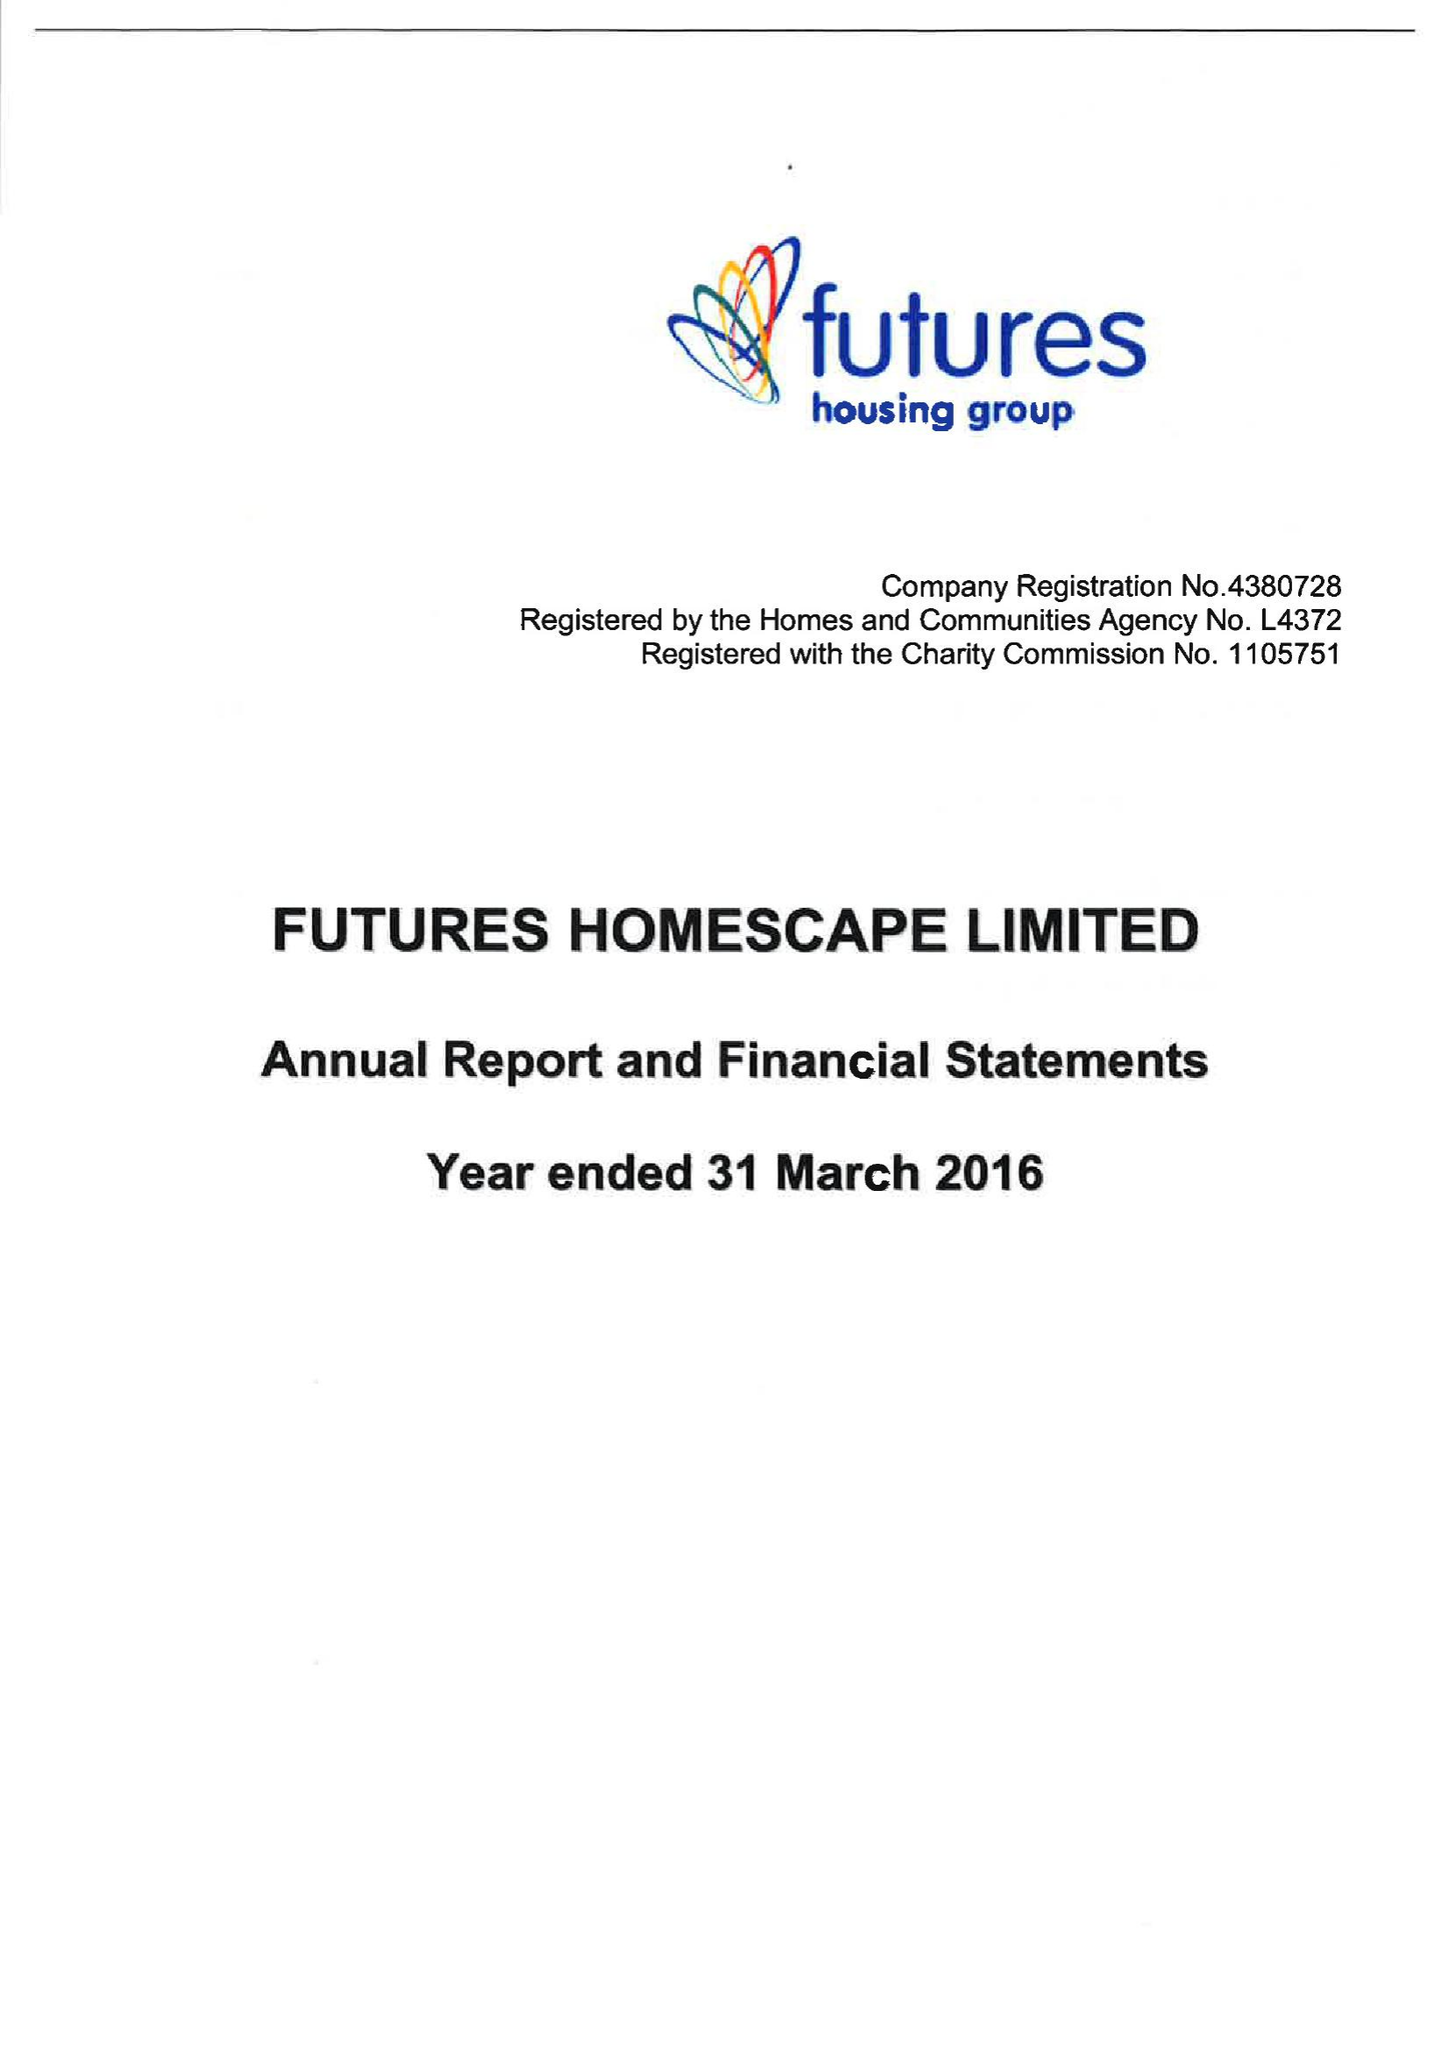What is the value for the address__street_line?
Answer the question using a single word or phrase. ASHER LANE 